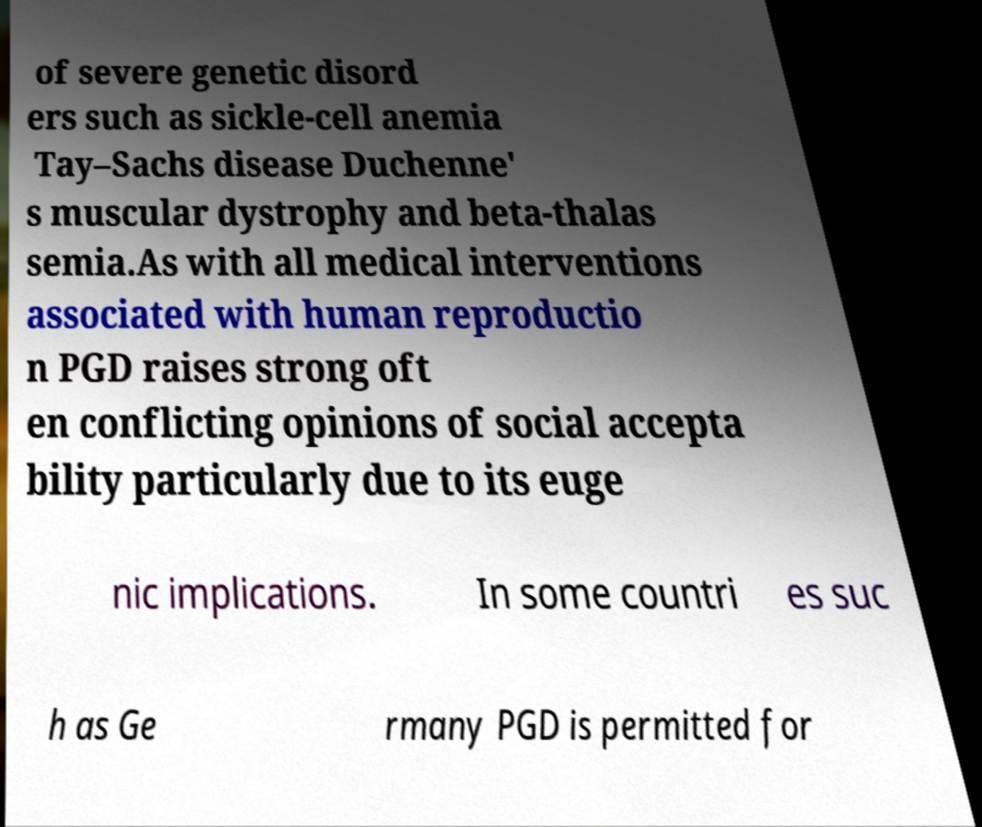What messages or text are displayed in this image? I need them in a readable, typed format. of severe genetic disord ers such as sickle-cell anemia Tay–Sachs disease Duchenne' s muscular dystrophy and beta-thalas semia.As with all medical interventions associated with human reproductio n PGD raises strong oft en conflicting opinions of social accepta bility particularly due to its euge nic implications. In some countri es suc h as Ge rmany PGD is permitted for 